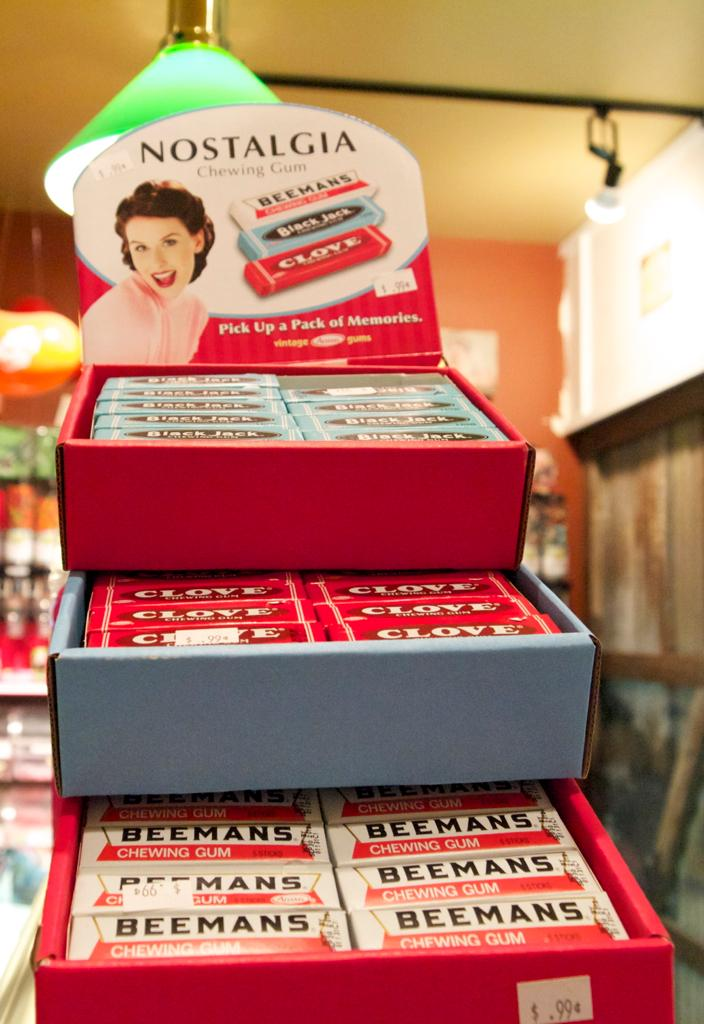<image>
Summarize the visual content of the image. a display at a store advertising beemans brand chewing gum 